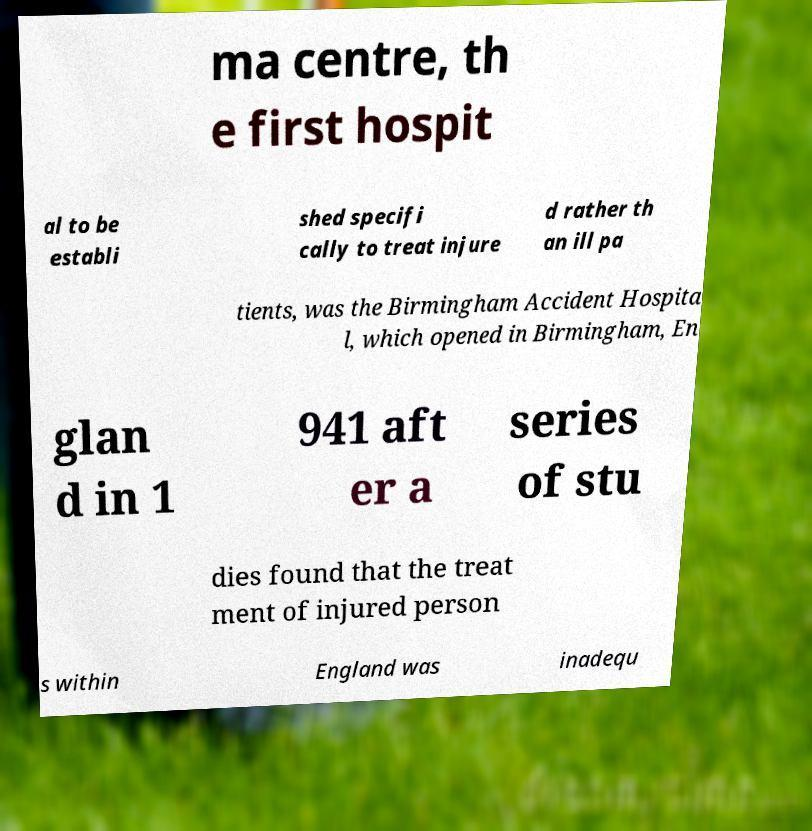For documentation purposes, I need the text within this image transcribed. Could you provide that? ma centre, th e first hospit al to be establi shed specifi cally to treat injure d rather th an ill pa tients, was the Birmingham Accident Hospita l, which opened in Birmingham, En glan d in 1 941 aft er a series of stu dies found that the treat ment of injured person s within England was inadequ 